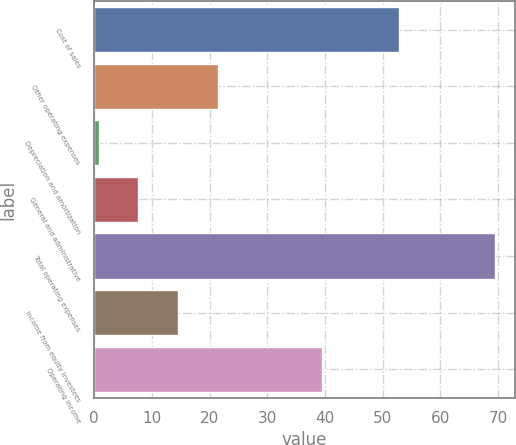Convert chart. <chart><loc_0><loc_0><loc_500><loc_500><bar_chart><fcel>Cost of sales<fcel>Other operating expenses<fcel>Depreciation and amortization<fcel>General and administrative<fcel>Total operating expenses<fcel>Income from equity investees<fcel>Operating income<nl><fcel>52.8<fcel>21.41<fcel>0.8<fcel>7.67<fcel>69.5<fcel>14.54<fcel>39.5<nl></chart> 